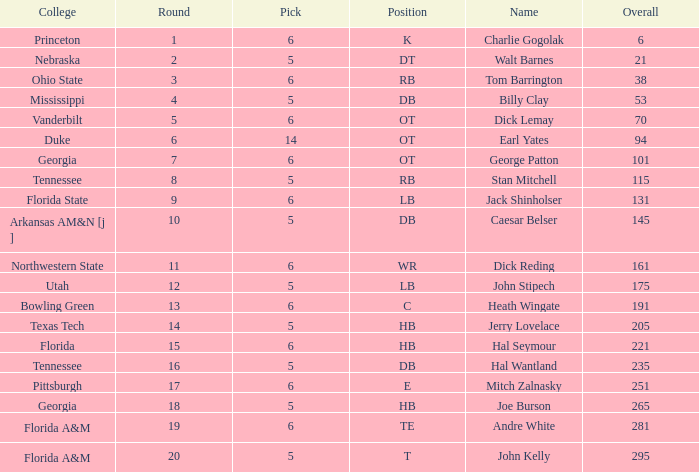What is the aggregate of overall when pick is more than 5, round is under 11, and name is "tom barrington"? 38.0. 